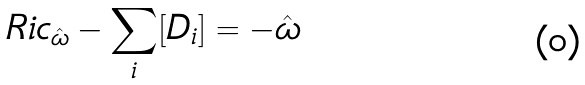Convert formula to latex. <formula><loc_0><loc_0><loc_500><loc_500>R i c _ { \hat { \omega } } - \sum _ { i } [ D _ { i } ] = - \hat { \omega }</formula> 